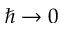Convert formula to latex. <formula><loc_0><loc_0><loc_500><loc_500>\hbar { \rightarrow } 0</formula> 